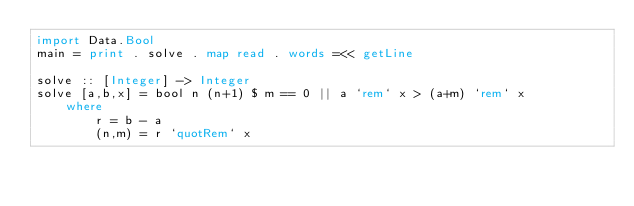Convert code to text. <code><loc_0><loc_0><loc_500><loc_500><_Haskell_>import Data.Bool
main = print . solve . map read . words =<< getLine

solve :: [Integer] -> Integer
solve [a,b,x] = bool n (n+1) $ m == 0 || a `rem` x > (a+m) `rem` x
    where
        r = b - a
        (n,m) = r `quotRem` x
</code> 